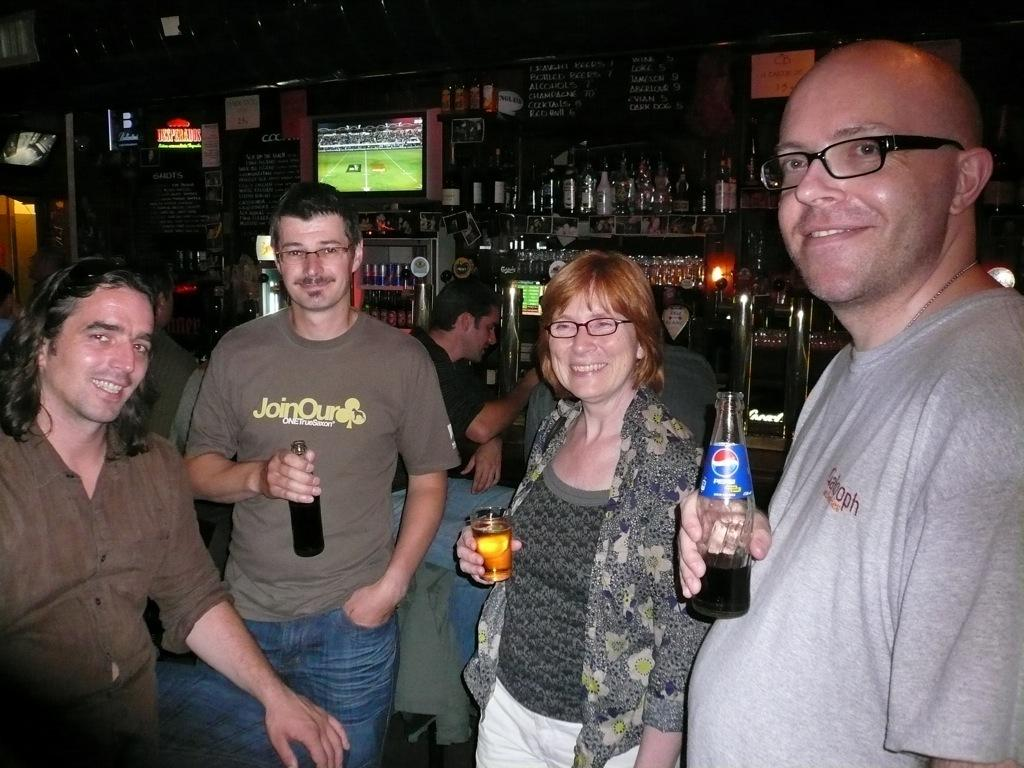How many people are present in the image? There are three men and a woman in the image, making a total of four people. What is the woman holding in her hands? The woman is holding a glass and a bottle. Can you describe the background of the image? In the background, there is another man, a few bottles, a screen, and a wall. What type of rose can be seen growing on the mountain in the image? There is no rose or mountain present in the image. Is the man wearing a cap in the image? There is no cap mentioned or visible in the image. 